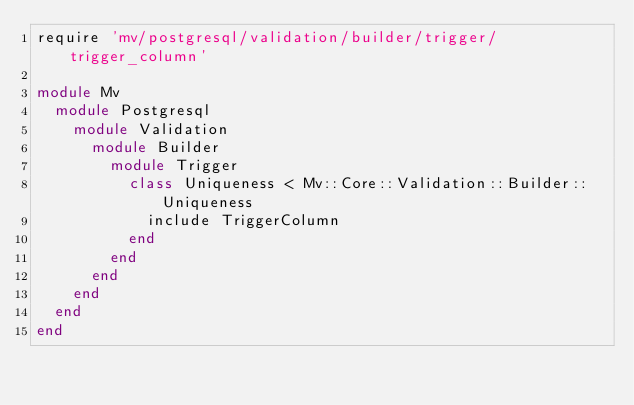Convert code to text. <code><loc_0><loc_0><loc_500><loc_500><_Ruby_>require 'mv/postgresql/validation/builder/trigger/trigger_column'

module Mv
  module Postgresql
    module Validation
      module Builder
        module Trigger
          class Uniqueness < Mv::Core::Validation::Builder::Uniqueness
            include TriggerColumn
          end
        end
      end
    end
  end
end</code> 